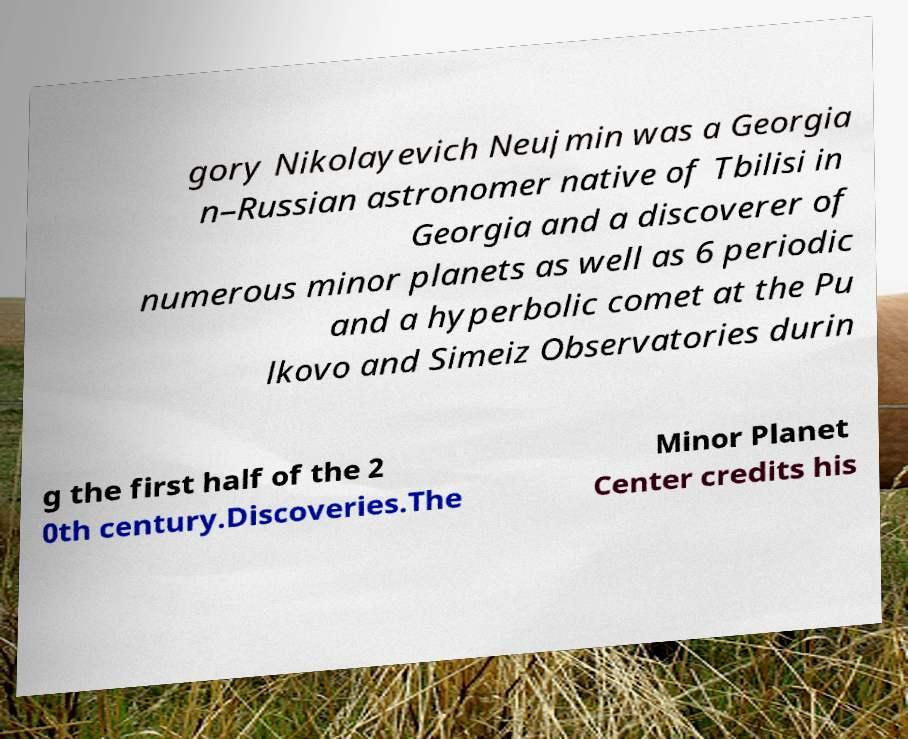I need the written content from this picture converted into text. Can you do that? gory Nikolayevich Neujmin was a Georgia n–Russian astronomer native of Tbilisi in Georgia and a discoverer of numerous minor planets as well as 6 periodic and a hyperbolic comet at the Pu lkovo and Simeiz Observatories durin g the first half of the 2 0th century.Discoveries.The Minor Planet Center credits his 